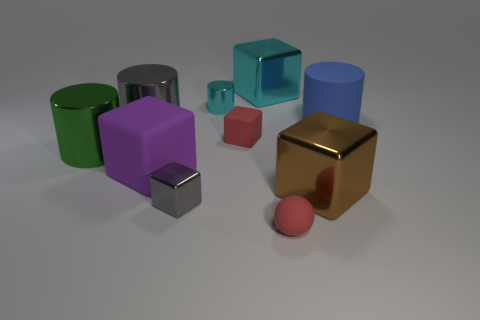What is the lighting like in the scene? Does it create any interesting effects? The lighting in the scene is soft and diffused, coming from above. It casts gentle shadows on the ground and creates subtle highlights on the surfaces of the objects, emphasizing their three-dimensional form. Is there any sense of movement or stillness in the image? The image conveys a sense of stillness. The objects are stationary, and there are no elements that suggest movement, thereby creating a static and calm composition. 